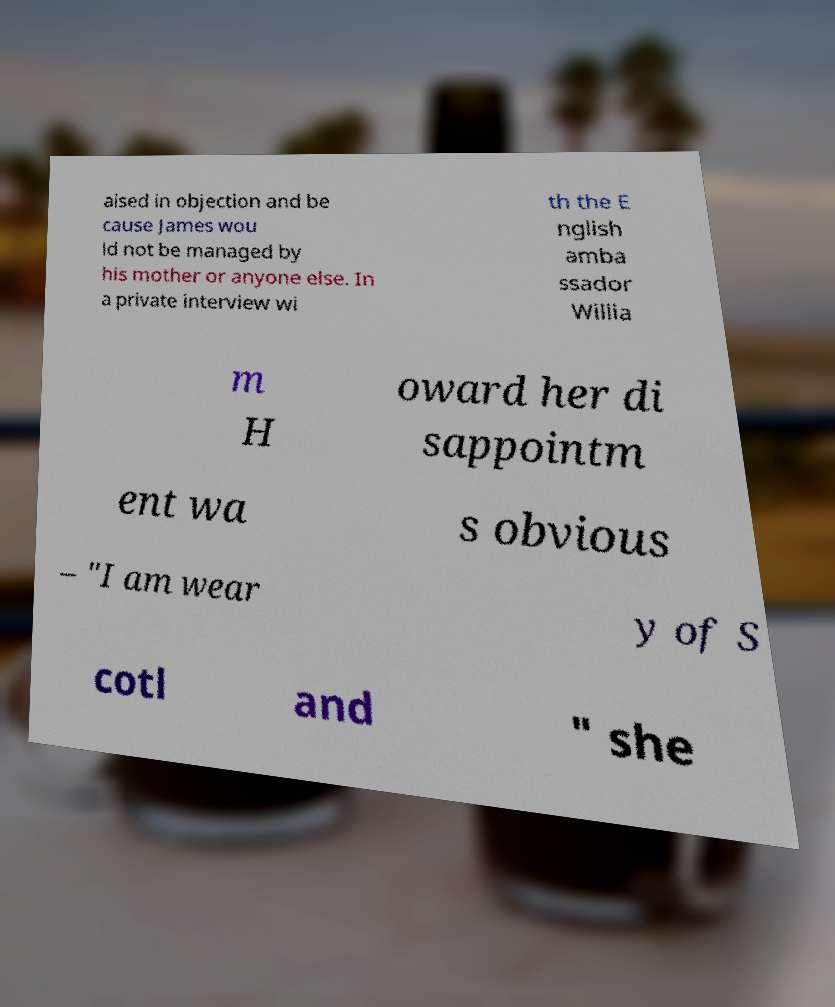Can you read and provide the text displayed in the image?This photo seems to have some interesting text. Can you extract and type it out for me? aised in objection and be cause James wou ld not be managed by his mother or anyone else. In a private interview wi th the E nglish amba ssador Willia m H oward her di sappointm ent wa s obvious – "I am wear y of S cotl and " she 